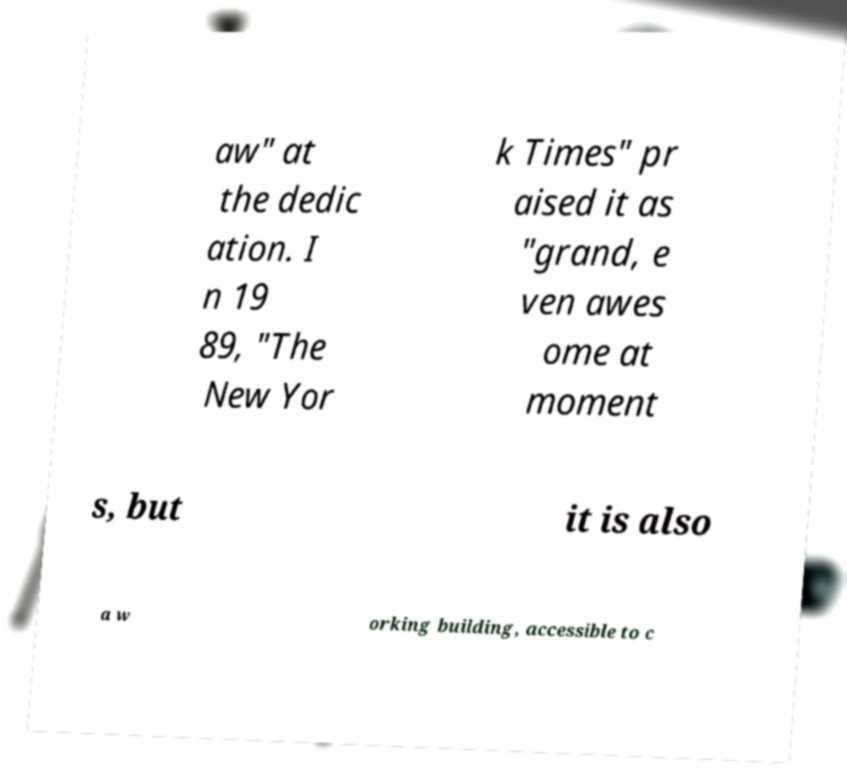For documentation purposes, I need the text within this image transcribed. Could you provide that? aw" at the dedic ation. I n 19 89, "The New Yor k Times" pr aised it as "grand, e ven awes ome at moment s, but it is also a w orking building, accessible to c 